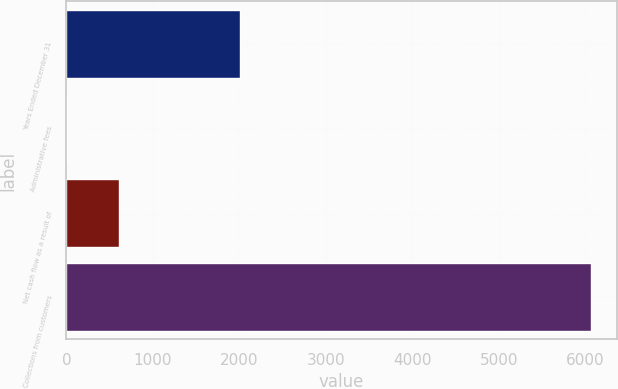<chart> <loc_0><loc_0><loc_500><loc_500><bar_chart><fcel>Years Ended December 31<fcel>Administrative fees<fcel>Net cash flow as a result of<fcel>Collections from customers<nl><fcel>2008<fcel>1<fcel>606.9<fcel>6060<nl></chart> 